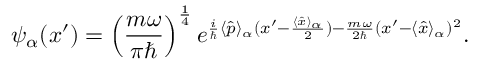<formula> <loc_0><loc_0><loc_500><loc_500>\psi _ { \alpha } ( x ^ { \prime } ) = \left ( { \frac { m \omega } { \pi } } \right ) ^ { \frac { 1 } { 4 } } e ^ { { \frac { i } { } } \langle { \hat { p } } \rangle _ { \alpha } ( x ^ { \prime } - { \frac { \langle { \hat { x } } \rangle _ { \alpha } } { 2 } } ) - { \frac { m \omega } { 2 } } ( x ^ { \prime } - \langle { \hat { x } } \rangle _ { \alpha } ) ^ { 2 } } .</formula> 